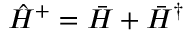<formula> <loc_0><loc_0><loc_500><loc_500>\hat { H } ^ { + } = \bar { H } + \bar { H } ^ { \dagger }</formula> 